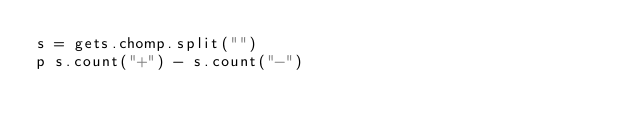Convert code to text. <code><loc_0><loc_0><loc_500><loc_500><_Ruby_>s = gets.chomp.split("")
p s.count("+") - s.count("-")</code> 